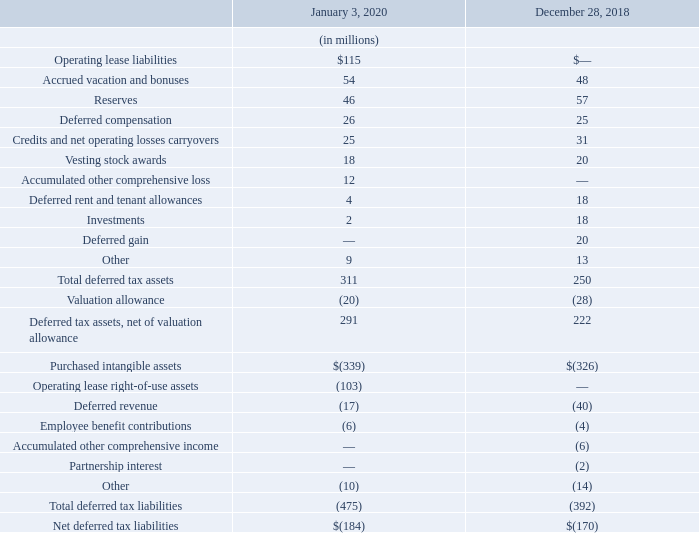Deferred income taxes are recorded for differences in the basis of assets and liabilities for financial reporting purposes and tax reporting purposes. Deferred tax assets (liabilities) were comprised of the following:
At January 3, 2020, the Company had state net operating losses of $77 million and state tax credits of $7 million. Both will begin to expire in fiscal 2020; however, the Company expects to utilize $24 million and $7 million of these state net operating losses and state tax credits, respectively. The Company also had foreign net operating losses of $44 million, which do not expire. The Company expects to utilize $9 million of these foreign net operating losses.
Our valuation allowance for deferred tax assets was $20 million and $28 million as of January 3, 2020 and December 28, 2018, respectively. The valuation allowance decreased by $8 million primarily due to the sale of the commercial cybersecurity business and releases related to the expected utilization of certain carryover attributes, partially offset by an increase related to foreign withholding taxes.
What were the state net operating losses in 2020? $77 million. What was the valuation allowance for deferred tax assets in 2020 and 2018 respectively? $20 million, $28 million. What was the Operating lease liabilities in 2020?
Answer scale should be: million. $115. In which period was Operating lease liabilities less than 100 million? Locate and analyze operating lease liability in row 3
Answer: 2018. What is the change in the Accrued vacation and bonuses from 2018 to 2020?
Answer scale should be: million. 54 - 48
Answer: 6. What is the change in the Reserves from 2018 to 2020?
Answer scale should be: million. 46 - 57
Answer: -11. 